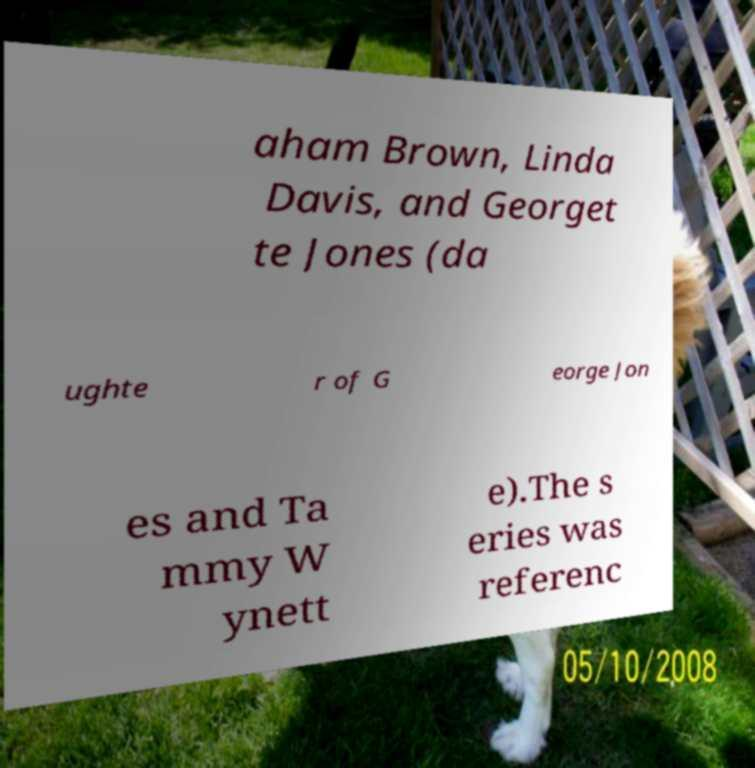Could you extract and type out the text from this image? aham Brown, Linda Davis, and Georget te Jones (da ughte r of G eorge Jon es and Ta mmy W ynett e).The s eries was referenc 